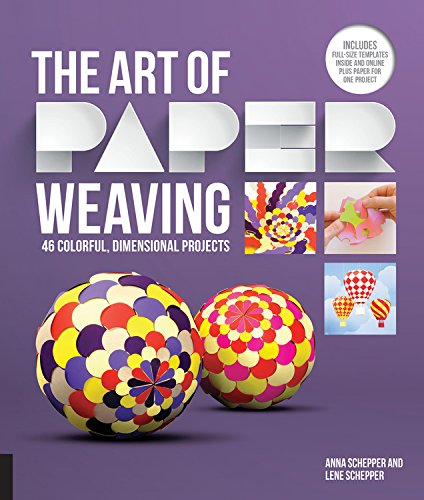What is the title of this book? The title of the book is 'The Art of Paper Weaving: 46 Colorful, Dimensional Projects--Includes Full-Size Templates Inside & Online Plus Practice Paper for One Project,' offering a comprehensive guide to crafting with paper. 